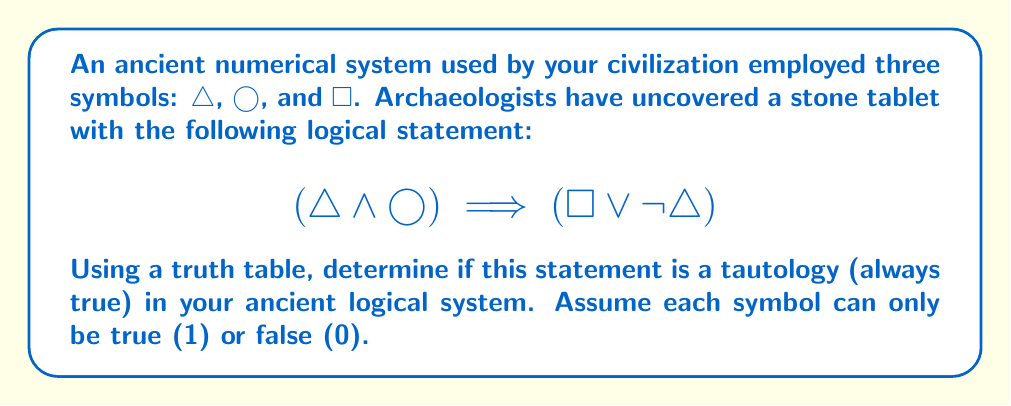Provide a solution to this math problem. To determine if the given statement is a tautology, we need to construct a truth table and evaluate the statement for all possible combinations of truth values for △, ◯, and ☐.

Step 1: Identify the number of rows in the truth table.
With 3 symbols, we need $2^3 = 8$ rows to cover all possible combinations.

Step 2: Construct the truth table.

$$ \begin{array}{c|c|c|c|c|c|c}
△ & ◯ & ☐ & △ \land ◯ & \neg △ & ☐ \lor \neg △ & (△ \land ◯) \implies (☐ \lor \neg △) \\
\hline
0 & 0 & 0 & 0 & 1 & 1 & 1 \\
0 & 0 & 1 & 0 & 1 & 1 & 1 \\
0 & 1 & 0 & 0 & 1 & 1 & 1 \\
0 & 1 & 1 & 0 & 1 & 1 & 1 \\
1 & 0 & 0 & 0 & 0 & 0 & 1 \\
1 & 0 & 1 & 0 & 0 & 1 & 1 \\
1 & 1 & 0 & 1 & 0 & 0 & 0 \\
1 & 1 & 1 & 1 & 0 & 1 & 1 \\
\end{array} $$

Step 3: Evaluate each column:
- $△ \land ◯$: True only when both △ and ◯ are true.
- $\neg △$: True when △ is false.
- $☐ \lor \neg △$: True when either ☐ is true or △ is false.
- $(△ \land ◯) \implies (☐ \lor \neg △)$: False only when the antecedent (△ \land ◯) is true and the consequent (☐ \lor \neg △) is false.

Step 4: Analyze the result.
The statement is false in only one case: when △ = 1, ◯ = 1, and ☐ = 0. In all other cases, it is true.

Therefore, the statement is not a tautology, as it is not true for all possible combinations of truth values.
Answer: The given statement $$(△ \land ◯) \implies (☐ \lor \neg △)$$ is not a tautology in the ancient logical system. 